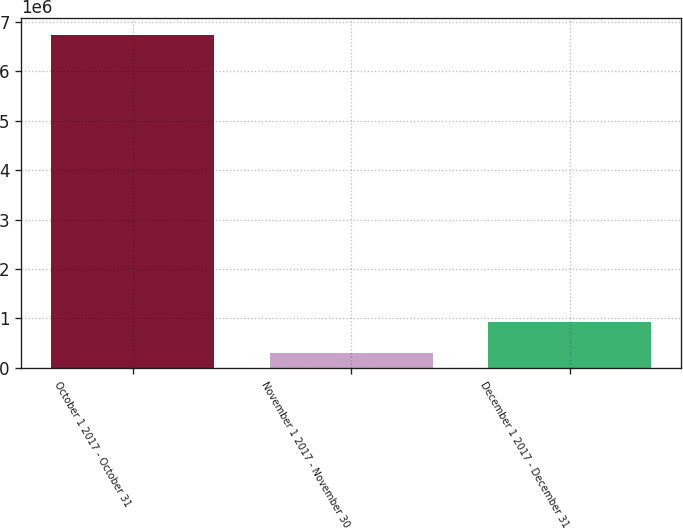<chart> <loc_0><loc_0><loc_500><loc_500><bar_chart><fcel>October 1 2017 - October 31<fcel>November 1 2017 - November 30<fcel>December 1 2017 - December 31<nl><fcel>6.73356e+06<fcel>290430<fcel>934743<nl></chart> 